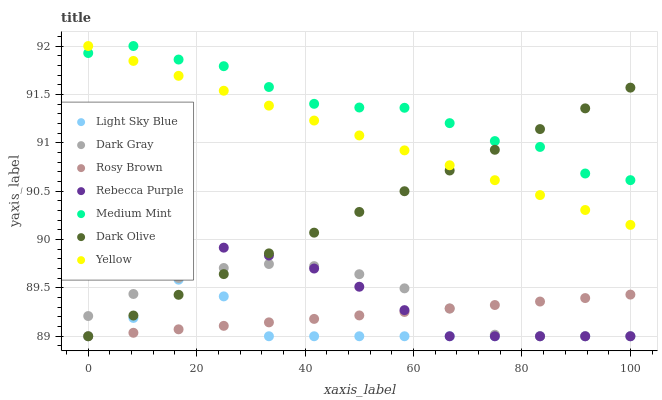Does Light Sky Blue have the minimum area under the curve?
Answer yes or no. Yes. Does Medium Mint have the maximum area under the curve?
Answer yes or no. Yes. Does Dark Olive have the minimum area under the curve?
Answer yes or no. No. Does Dark Olive have the maximum area under the curve?
Answer yes or no. No. Is Yellow the smoothest?
Answer yes or no. Yes. Is Light Sky Blue the roughest?
Answer yes or no. Yes. Is Dark Olive the smoothest?
Answer yes or no. No. Is Dark Olive the roughest?
Answer yes or no. No. Does Dark Olive have the lowest value?
Answer yes or no. Yes. Does Yellow have the lowest value?
Answer yes or no. No. Does Yellow have the highest value?
Answer yes or no. Yes. Does Dark Olive have the highest value?
Answer yes or no. No. Is Rebecca Purple less than Medium Mint?
Answer yes or no. Yes. Is Yellow greater than Rosy Brown?
Answer yes or no. Yes. Does Rosy Brown intersect Dark Olive?
Answer yes or no. Yes. Is Rosy Brown less than Dark Olive?
Answer yes or no. No. Is Rosy Brown greater than Dark Olive?
Answer yes or no. No. Does Rebecca Purple intersect Medium Mint?
Answer yes or no. No. 